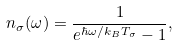<formula> <loc_0><loc_0><loc_500><loc_500>n _ { \sigma } ( \omega ) = \frac { 1 } { e ^ { \hbar { \omega } / k _ { B } T _ { \sigma } } - 1 } ,</formula> 